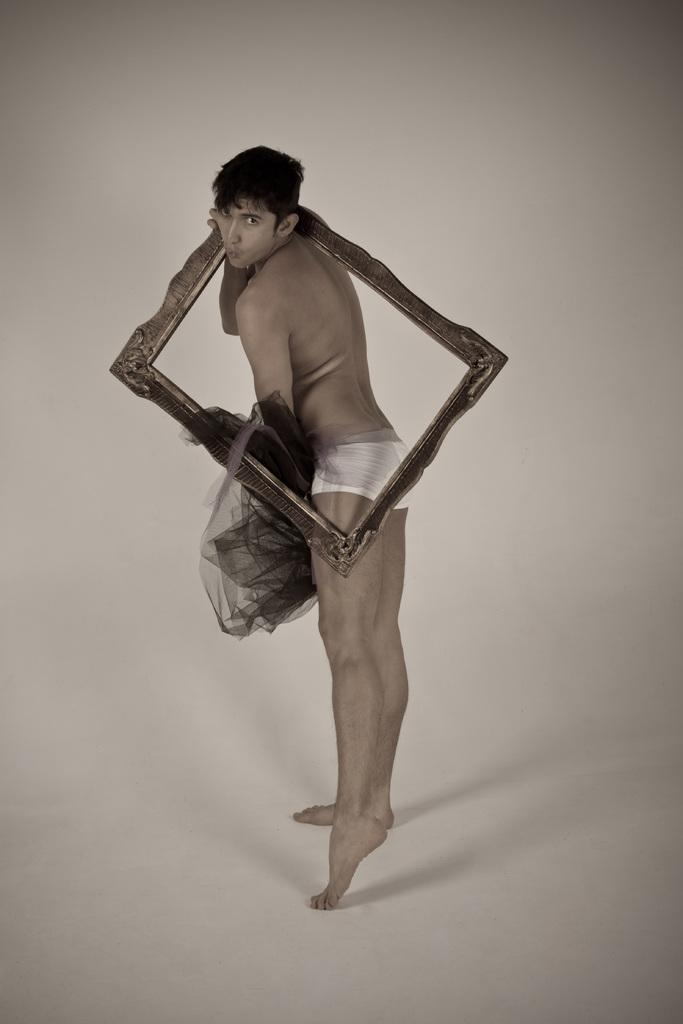What is the main subject of the image? There is a person in the image. What is the person holding in the image? The person is holding a frame and another object. What is the person standing on in the image? The person is standing on a white surface. Can you see a crown on the person's head in the image? There is no crown visible on the person's head in the image. What park is the person visiting in the image? The image does not show the person visiting a park. 